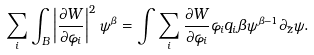<formula> <loc_0><loc_0><loc_500><loc_500>\sum _ { i } \int _ { B } \left | \frac { \partial W } { \partial \varphi _ { i } } \right | ^ { 2 } \psi ^ { \beta } = \int \sum _ { i } \frac { \partial W } { \partial \varphi _ { i } } \varphi _ { i } q _ { i } \beta \psi ^ { \beta - 1 } \partial _ { \bar { z } } \psi .</formula> 